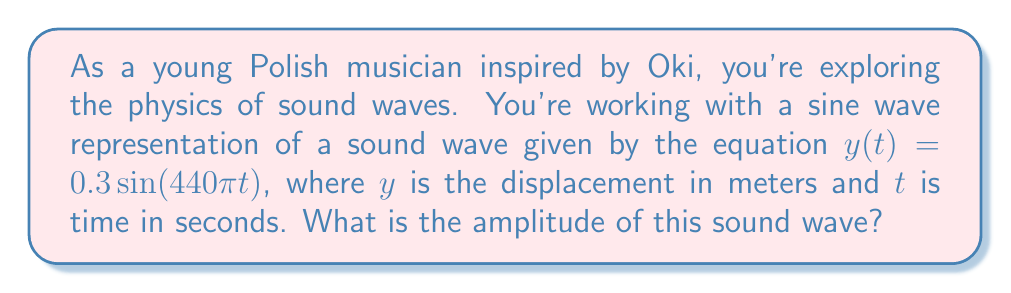What is the answer to this math problem? To determine the amplitude of a sound wave represented by a sine function, we need to understand the general form of a sine wave equation:

$$y(t) = A \sin(2\pi ft + \phi)$$

Where:
- $A$ is the amplitude
- $f$ is the frequency
- $t$ is time
- $\phi$ is the phase shift

In our case, we have the equation:

$$y(t) = 0.3 \sin(440\pi t)$$

Comparing this to the general form, we can see that:

1. The coefficient in front of the sine function is the amplitude.
2. The argument inside the sine function $(440\pi t)$ represents $2\pi ft$.

Therefore:

1. The amplitude $A$ is directly given as 0.3 meters.
2. We can also determine that the frequency is 220 Hz (since $2\pi f = 440\pi$), but this isn't necessary for finding the amplitude.

The amplitude of a sound wave represents the maximum displacement from the equilibrium position. In a sine wave, this is the value by which the sine function is multiplied.
Answer: The amplitude of the sound wave is 0.3 meters. 